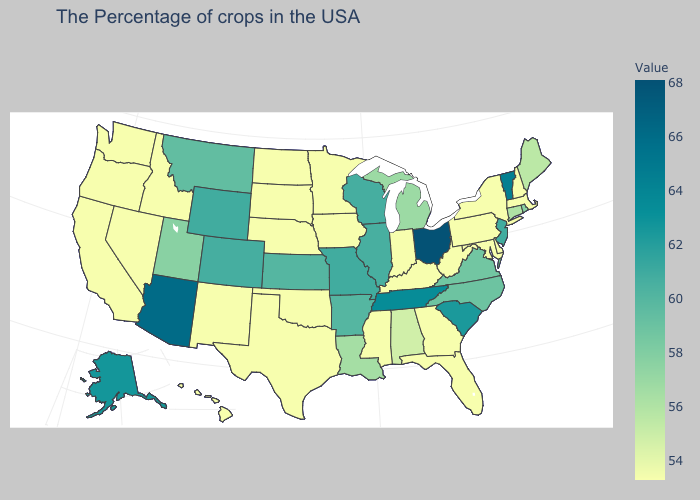Does the map have missing data?
Quick response, please. No. Does the map have missing data?
Short answer required. No. Does the map have missing data?
Keep it brief. No. 